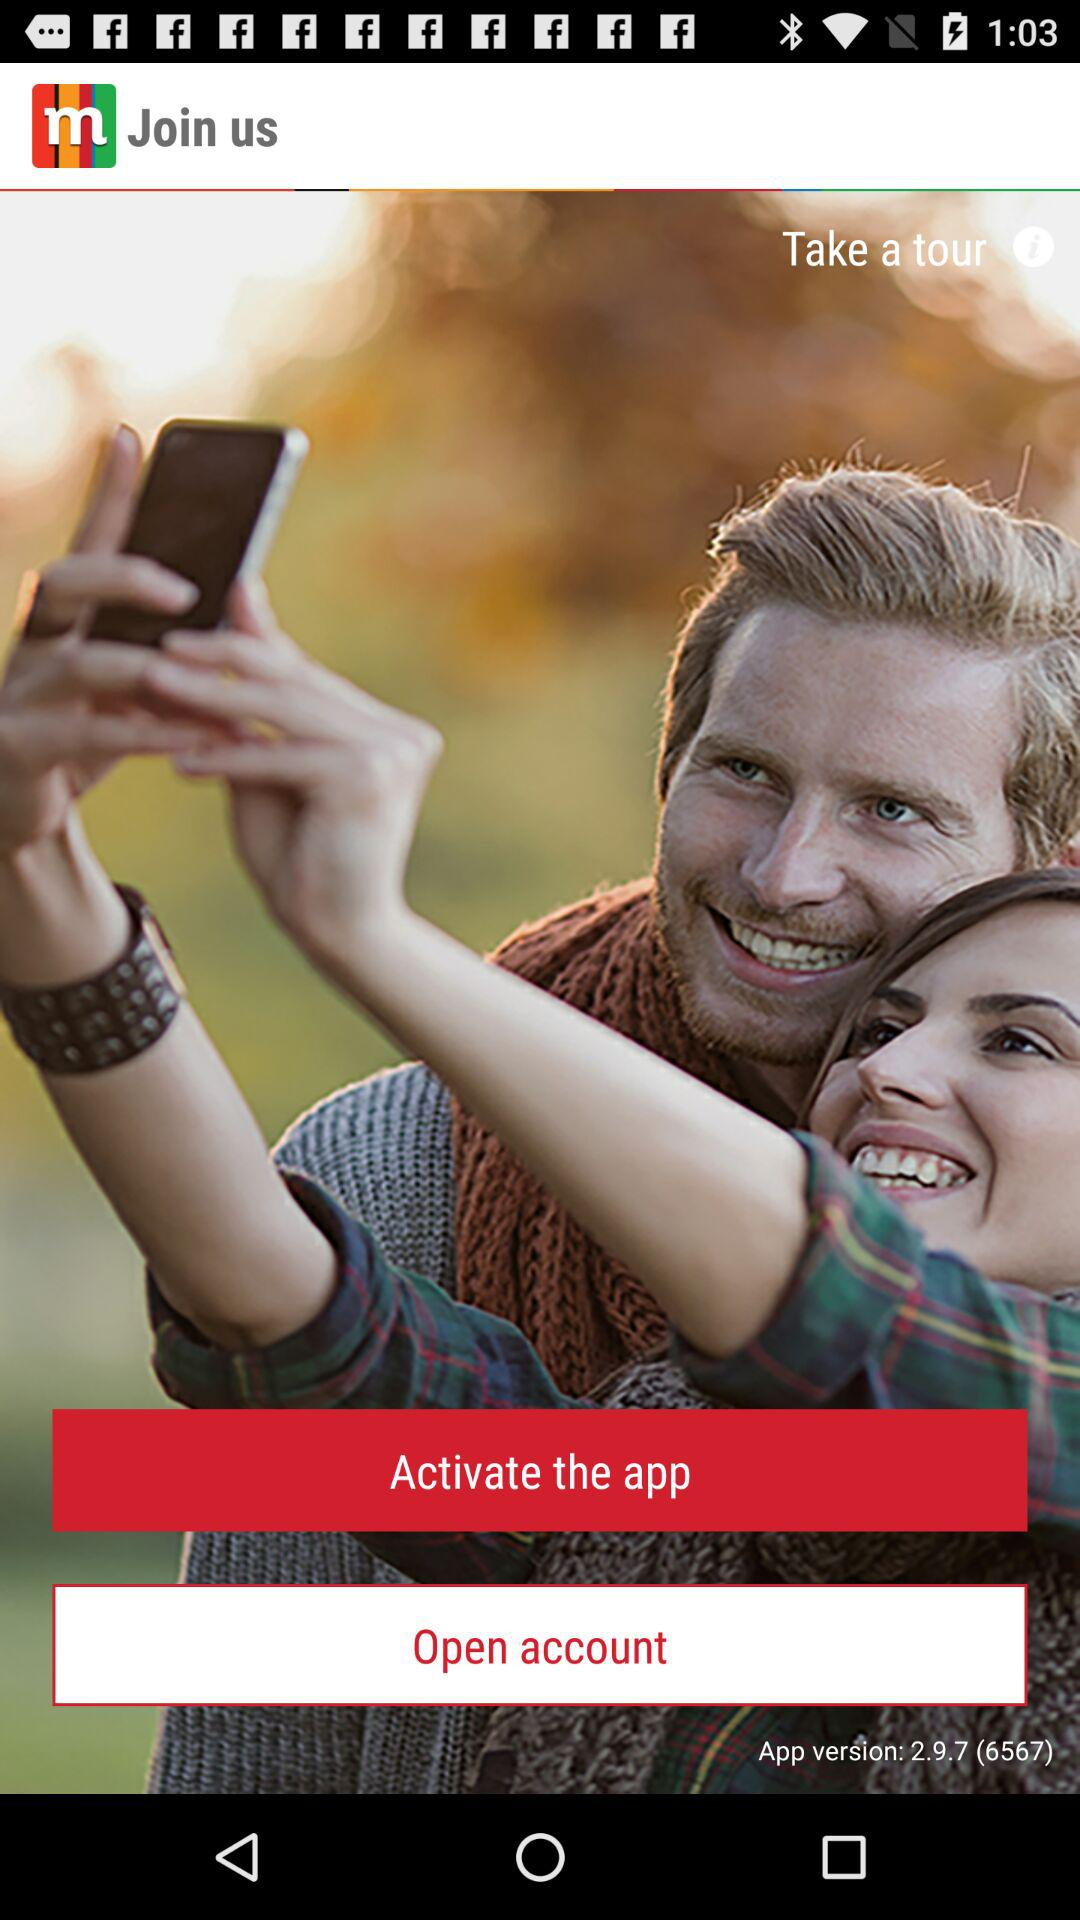What is the version of the application? The version of the application is 2.9.7 (6567). 